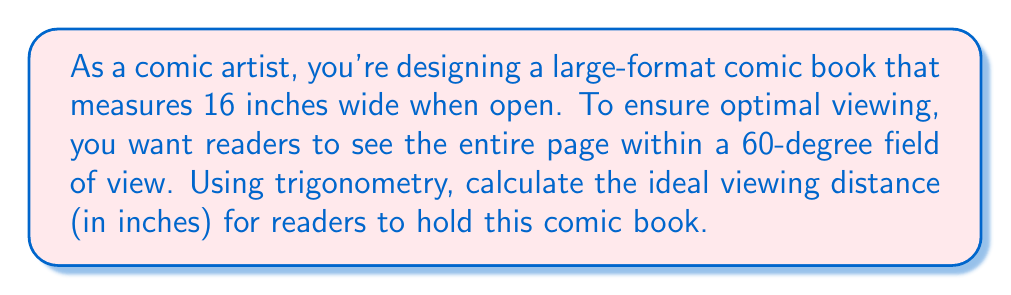Could you help me with this problem? Let's approach this step-by-step using trigonometry:

1) First, let's visualize the problem:
   [asy]
   import geometry;
   
   size(200);
   
   pair A = (0,0), B = (8,0), C = (0,8);
   draw(A--B--C--A);
   
   label("8\"", (4,0), S);
   label("Viewing Distance", (0,4), W);
   label("30°", (0,0), NE);
   
   draw(arc(A,1,0,30), Arrow);
   [/asy]

2) We're dealing with a right triangle where:
   - The adjacent side is the viewing distance we're looking for
   - The opposite side is half the width of the open comic (8 inches)
   - The angle is half of the 60-degree field of view (30 degrees)

3) We can use the tangent function to solve this:

   $$\tan(\theta) = \frac{\text{opposite}}{\text{adjacent}}$$

4) Plugging in our values:

   $$\tan(30°) = \frac{8}{\text{viewing distance}}$$

5) Rearranging to solve for viewing distance:

   $$\text{viewing distance} = \frac{8}{\tan(30°)}$$

6) We know that $\tan(30°) = \frac{1}{\sqrt{3}}$, so:

   $$\text{viewing distance} = 8 \cdot \sqrt{3} \approx 13.86 \text{ inches}$$

Therefore, the ideal viewing distance is approximately 13.86 inches.
Answer: $8\sqrt{3} \approx 13.86$ inches 